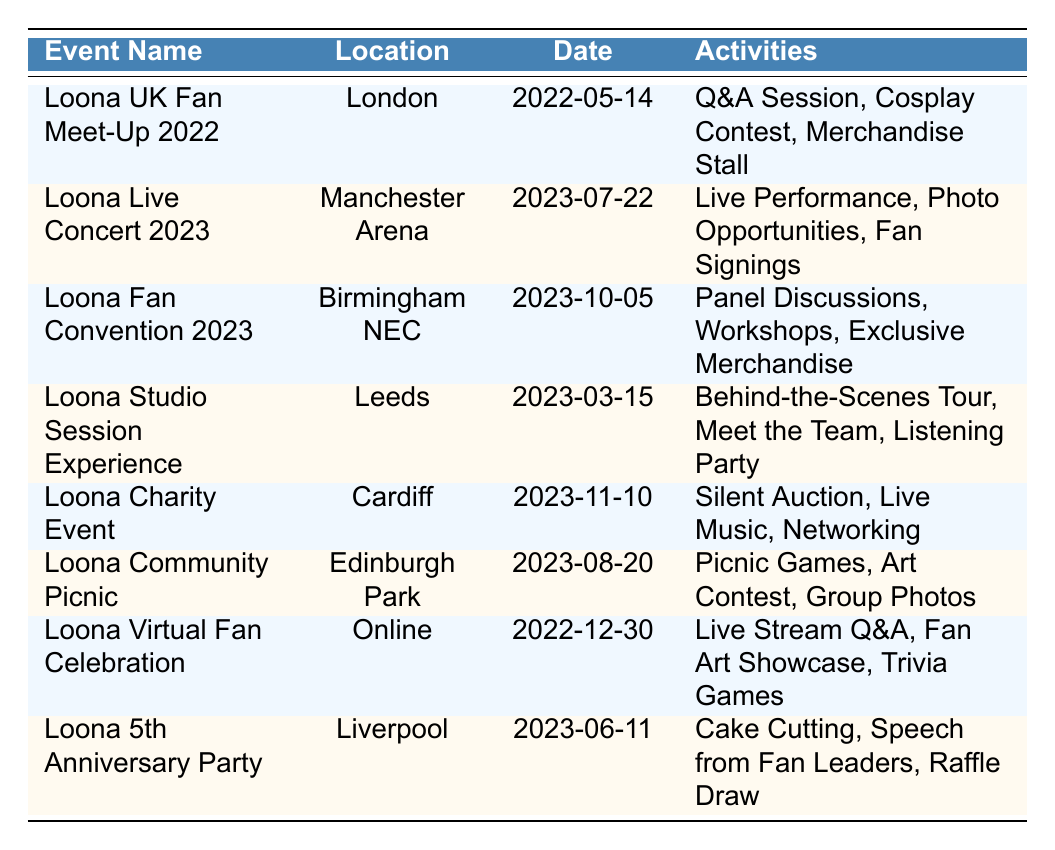What is the attendance for the Loona Live Concert 2023? The table indicates the attendance number listed under the event "Loona Live Concert 2023." It states that 3000 fans attended this event.
Answer: 3000 Which event had the least attendance? By examining the attendance numbers for each event listed in the table, the "Loona Studio Session Experience" had the lowest attendance of 50.
Answer: 50 How many events were held in 2023? The table lists all events and their respective dates. By filtering through, five events are marked in 2023. These events are the "Loona Live Concert 2023," "Loona Fan Convention 2023," "Loona Studio Session Experience," "Loona Charity Event," and "Loona Community Picnic."
Answer: 5 What is the total attendance from all events? To find the total attendance, we sum the attendance figures from each event. The calculation is: 150 + 3000 + 800 + 50 + 200 + 100 + 500 + 250 = 5100.
Answer: 5100 Did the Loona Community Picnic occur before the Loona Charity Event? By checking the dates of both events, the "Loona Community Picnic" on August 20, 2023, occurred before the "Loona Charity Event" on November 10, 2023, making the statement true.
Answer: Yes What is the average attendance for the events held in 2023? First, we identify the events in 2023, which have a total attendance of 3000 + 800 + 50 + 200 + 100 = 4150 across five events. Next, we calculate the average by dividing the total attendance by the number of events: 4150 / 5 = 830.
Answer: 830 What types of activities were included in the Loona 5th Anniversary Party? The table lists activities under each event, specifically for the "Loona 5th Anniversary Party," which featured cake cutting, speeches from fan leaders, and a raffle draw.
Answer: Cake Cutting, Speech from Fan Leaders, Raffle Draw Was the Loona Virtual Fan Celebration attended by more fans than the Loona UK Fan Meet-Up 2022? Comparing the attendance numbers, the "Loona Virtual Fan Celebration" attracted 500 fans whereas the "Loona UK Fan Meet-Up 2022" had 150 attendees. The number of attendees for the virtual event exceeds that of the meet-up.
Answer: Yes 